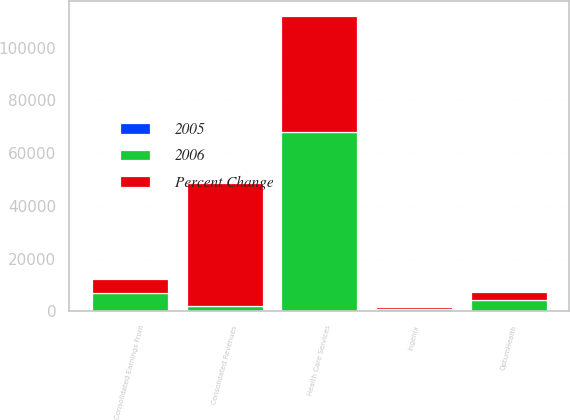Convert chart. <chart><loc_0><loc_0><loc_500><loc_500><stacked_bar_chart><ecel><fcel>Health Care Services<fcel>OptumHealth<fcel>Ingenix<fcel>Consolidated Revenues<fcel>Consolidated Earnings From<nl><fcel>2006<fcel>67817<fcel>4342<fcel>956<fcel>2041.5<fcel>6984<nl><fcel>Percent Change<fcel>44119<fcel>3127<fcel>796<fcel>46425<fcel>5080<nl><fcel>2005<fcel>54<fcel>39<fcel>20<fcel>54<fcel>37<nl></chart> 